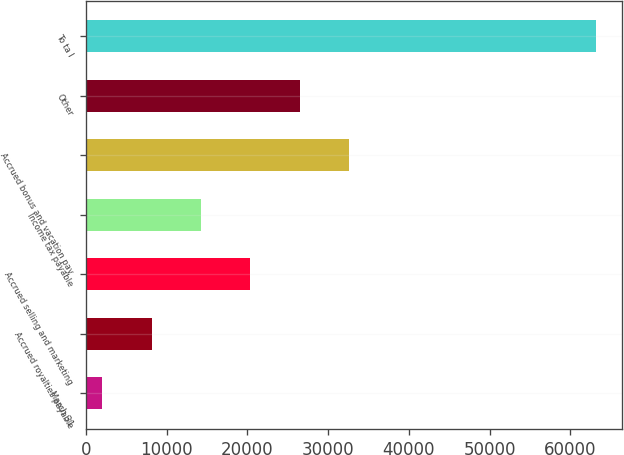Convert chart to OTSL. <chart><loc_0><loc_0><loc_500><loc_500><bar_chart><fcel>March 31<fcel>Accrued royalties payable<fcel>Accrued selling and marketing<fcel>Income tax payable<fcel>Accrued bonus and vacation pay<fcel>Other<fcel>To ta l<nl><fcel>2004<fcel>8124.1<fcel>20364.3<fcel>14244.2<fcel>32604.5<fcel>26484.4<fcel>63205<nl></chart> 